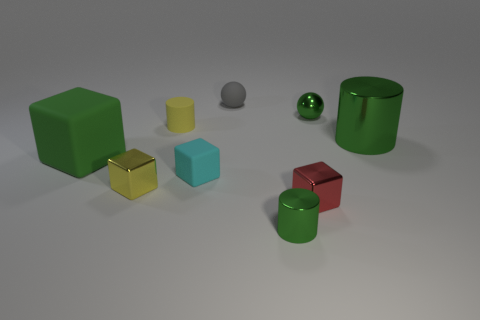Subtract all cyan cubes. How many green cylinders are left? 2 Subtract all large cubes. How many cubes are left? 3 Subtract all red blocks. How many blocks are left? 3 Add 1 small blocks. How many objects exist? 10 Subtract all gray blocks. Subtract all cyan spheres. How many blocks are left? 4 Subtract all spheres. How many objects are left? 7 Subtract all metallic blocks. Subtract all red objects. How many objects are left? 6 Add 8 small yellow cubes. How many small yellow cubes are left? 9 Add 9 small yellow metallic cubes. How many small yellow metallic cubes exist? 10 Subtract 1 green spheres. How many objects are left? 8 